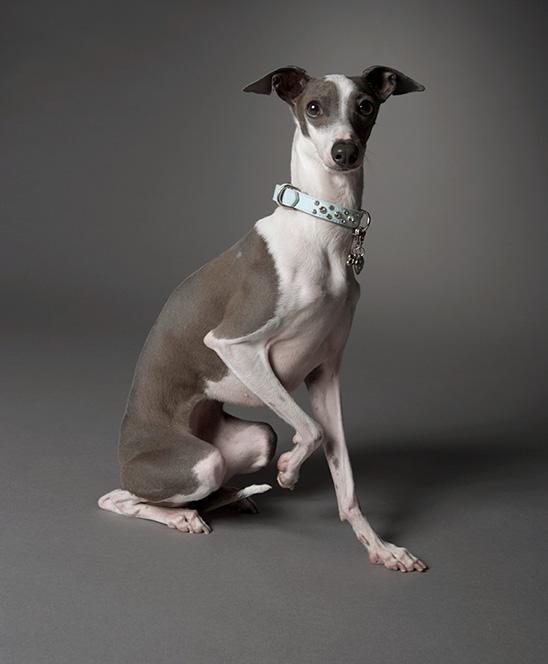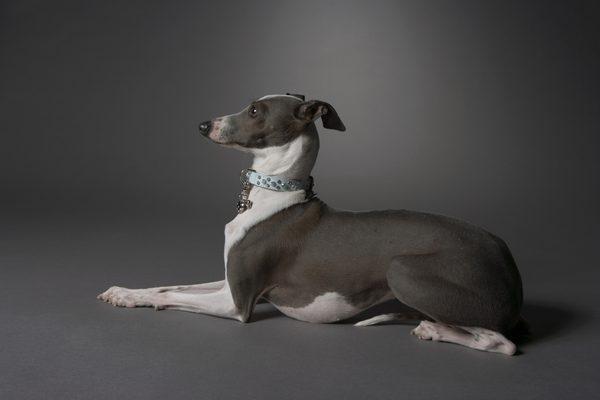The first image is the image on the left, the second image is the image on the right. For the images displayed, is the sentence "There are more dogs in the right image than in the left." factually correct? Answer yes or no. No. The first image is the image on the left, the second image is the image on the right. For the images shown, is this caption "All dogs are wearing fancy, colorful collars." true? Answer yes or no. Yes. 